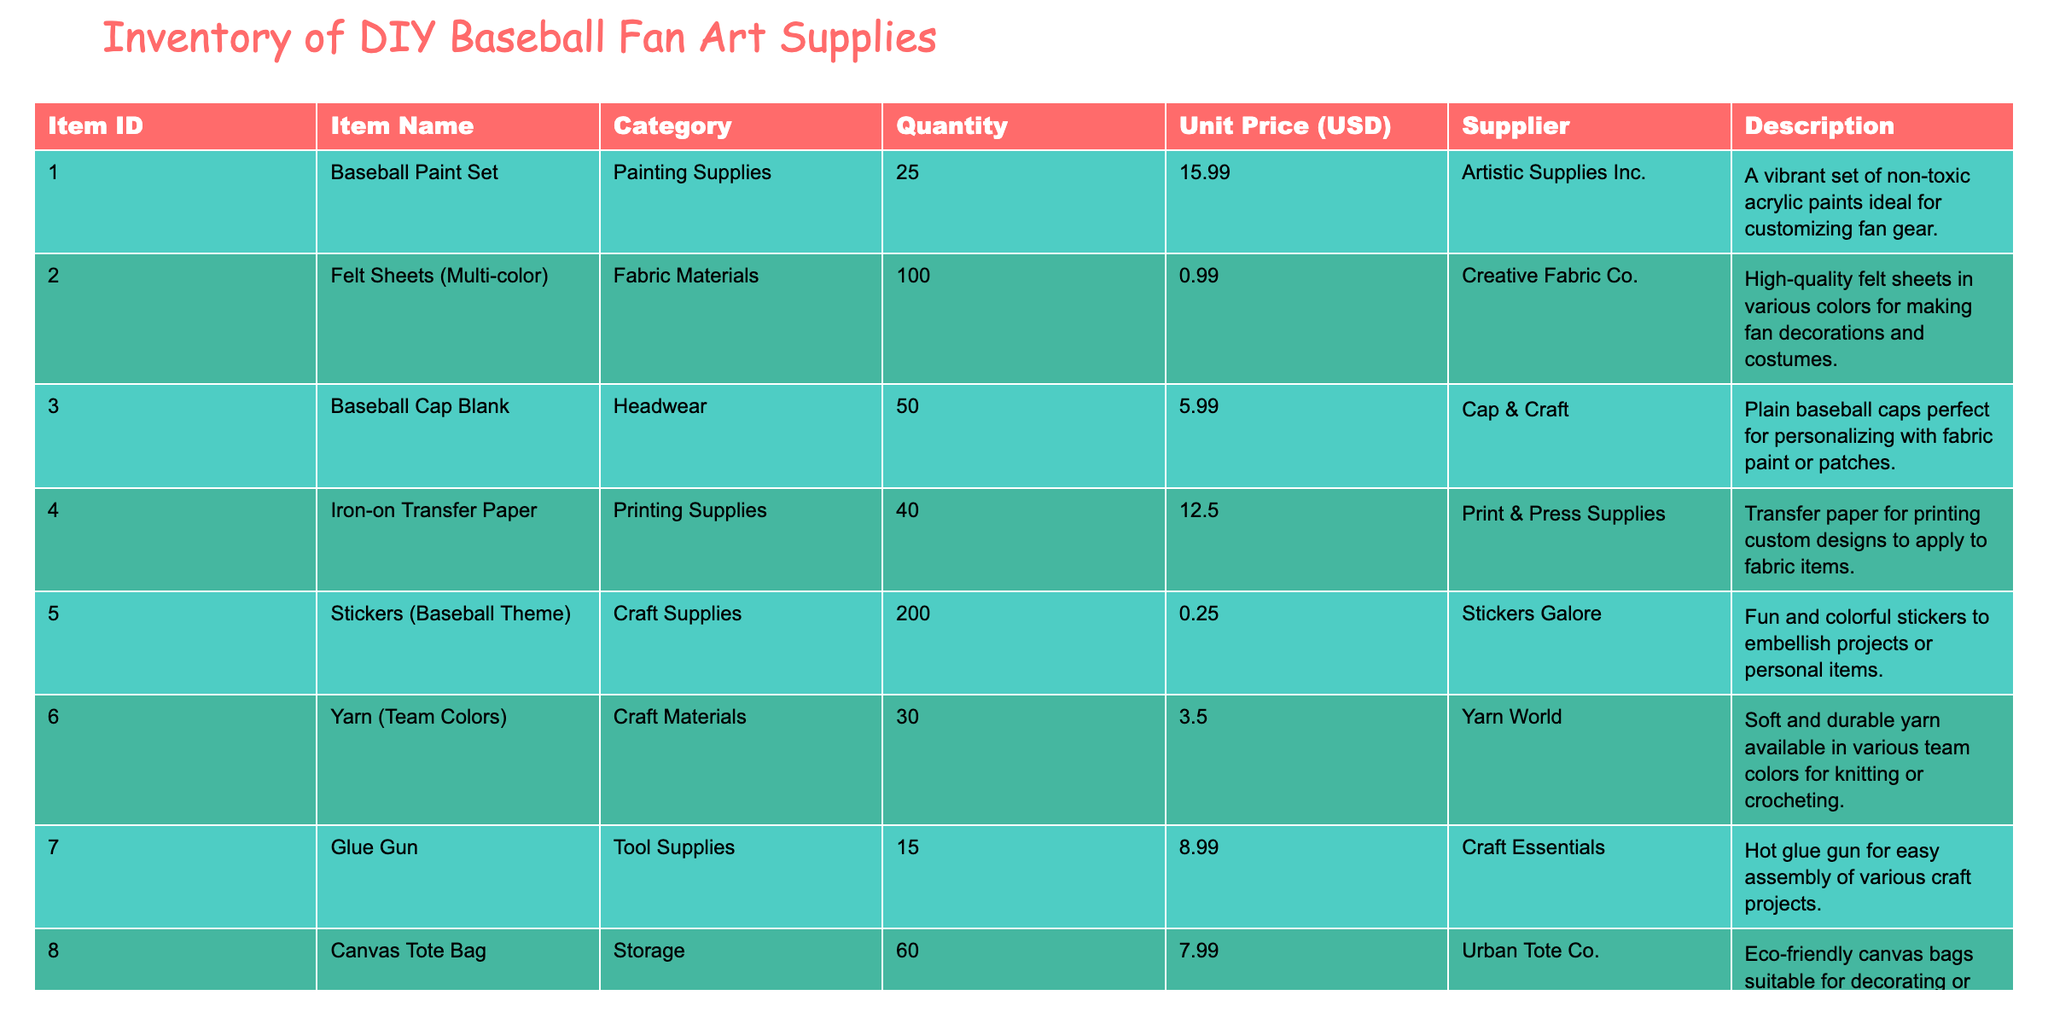What is the total quantity of stickers available in the inventory? The quantity of stickers (Baseball Theme) in the inventory is listed under the Quantity column. According to the table, there are 200 stickers available.
Answer: 200 How much would it cost to purchase all 25 sets of baseball paint? To find the total cost for 25 sets, multiply the quantity (25) by the unit price (15.99 USD). The calculation is 25 * 15.99 = 399.75 USD.
Answer: 399.75 Is there more than one type of headwear listed in the inventory? The table shows the headwear category has one item, which is a Baseball Cap Blank. Therefore, the statement is false as there is not more than one type.
Answer: No What is the total cost of all items in the inventory? To calculate the total cost, we multiply the Quantity by the Unit Price for each item and then sum these amounts. The breakdown is as follows: (25 * 15.99) + (100 * 0.99) + (50 * 5.99) + (40 * 12.50) + (200 * 0.25) + (30 * 3.50) + (15 * 8.99) + (60 * 7.99) + (20 * 12.99) + (50 * 2.50) = 399.75 + 99.00 + 299.50 + 500.00 + 50.00 + 105.00 + 134.85 + 479.40 + 259.80 + 125.00 = 2053.30 USD.
Answer: 2053.30 What is the average unit price of the items under the Craft Materials category? The Craft Materials category includes only one item: Yarn (Team Colors) with a unit price of 3.50 USD. Since there is only one item, the average is the same as the unit price.
Answer: 3.50 